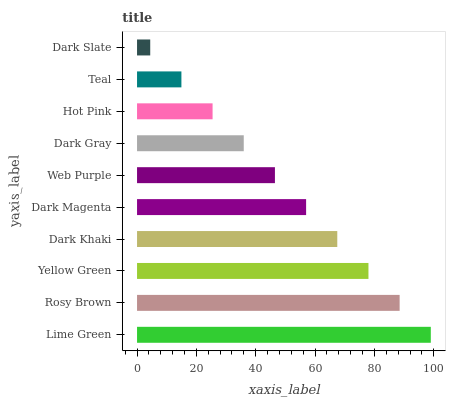Is Dark Slate the minimum?
Answer yes or no. Yes. Is Lime Green the maximum?
Answer yes or no. Yes. Is Rosy Brown the minimum?
Answer yes or no. No. Is Rosy Brown the maximum?
Answer yes or no. No. Is Lime Green greater than Rosy Brown?
Answer yes or no. Yes. Is Rosy Brown less than Lime Green?
Answer yes or no. Yes. Is Rosy Brown greater than Lime Green?
Answer yes or no. No. Is Lime Green less than Rosy Brown?
Answer yes or no. No. Is Dark Magenta the high median?
Answer yes or no. Yes. Is Web Purple the low median?
Answer yes or no. Yes. Is Dark Gray the high median?
Answer yes or no. No. Is Teal the low median?
Answer yes or no. No. 